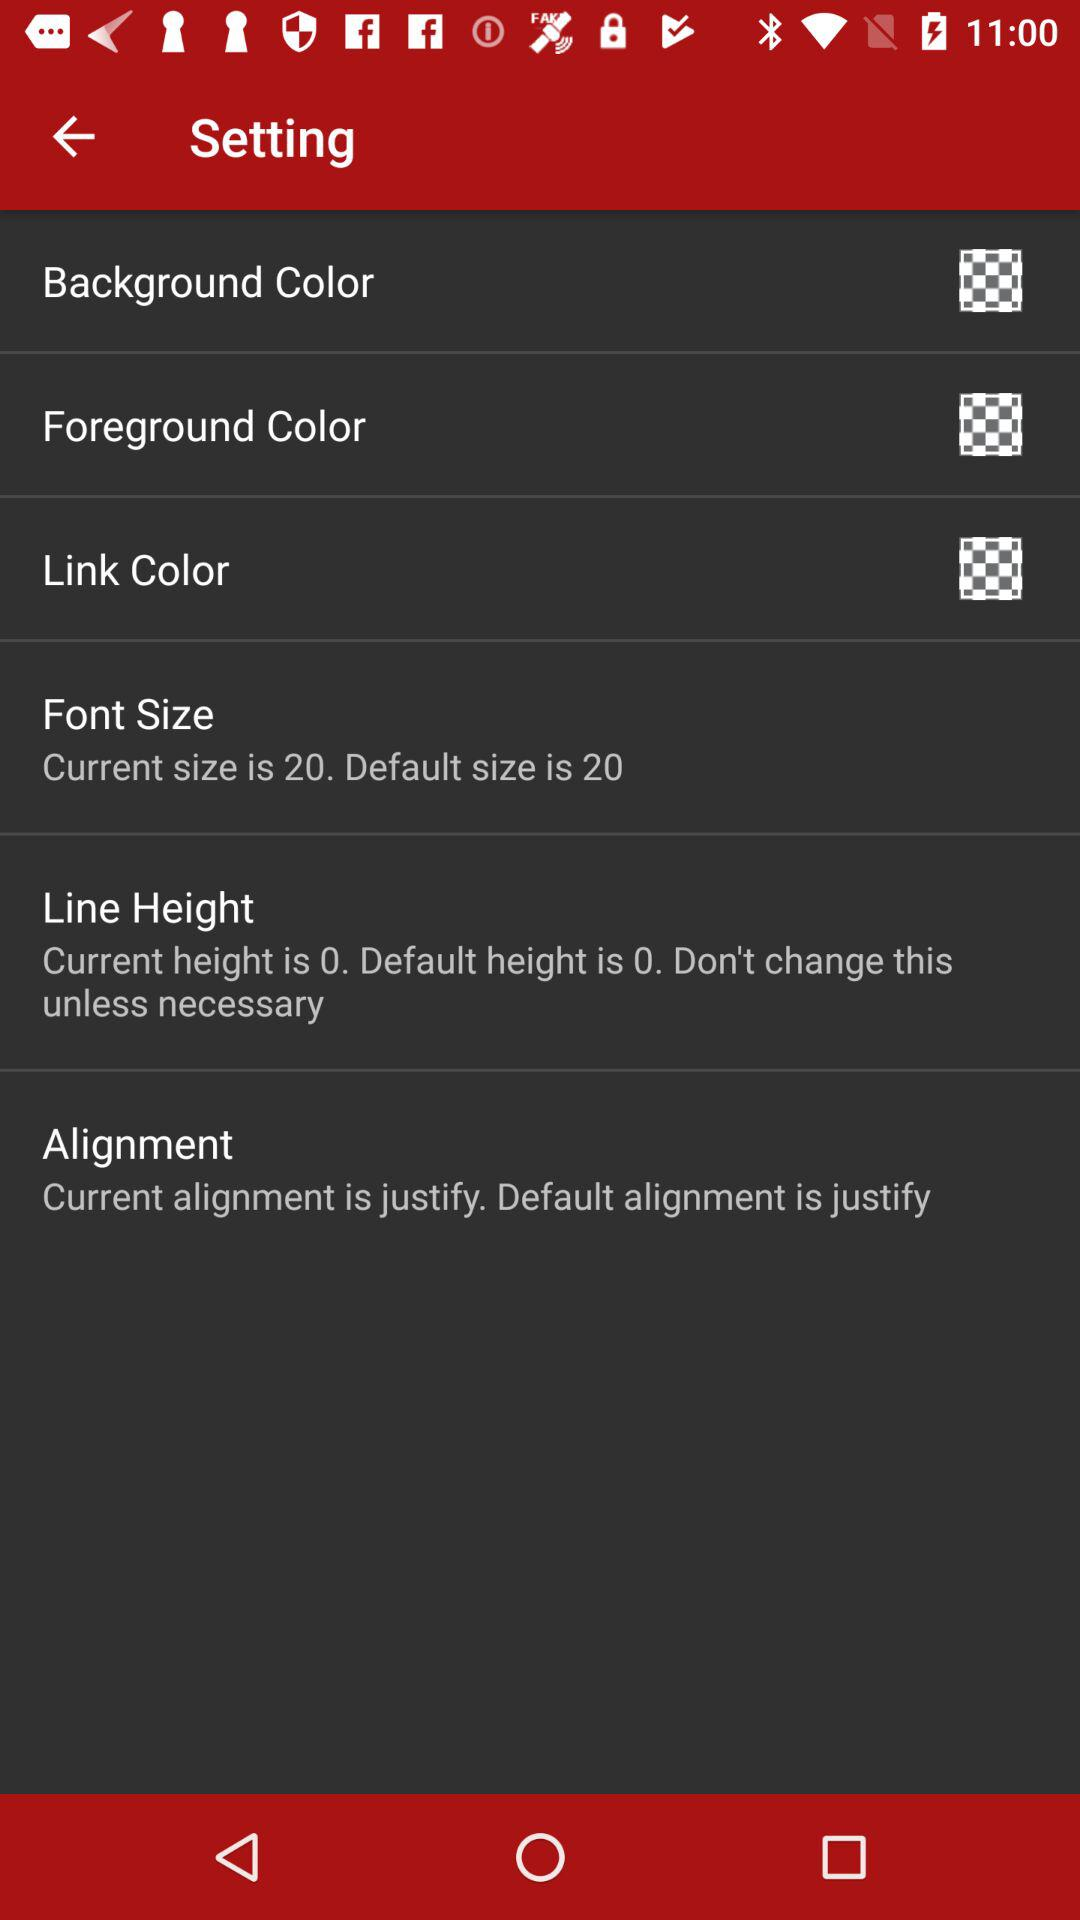What is the default alignment? The default alignment is "justify". 